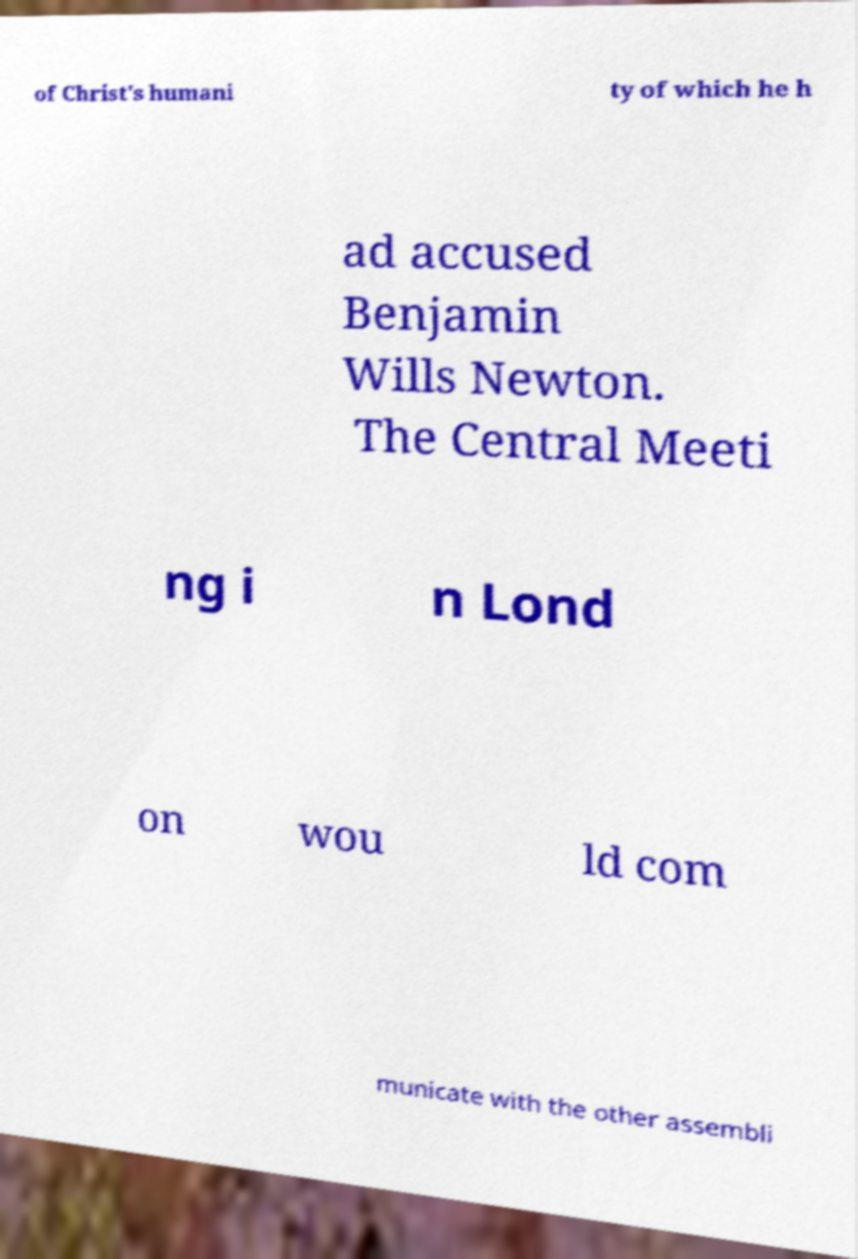Could you extract and type out the text from this image? of Christ's humani ty of which he h ad accused Benjamin Wills Newton. The Central Meeti ng i n Lond on wou ld com municate with the other assembli 